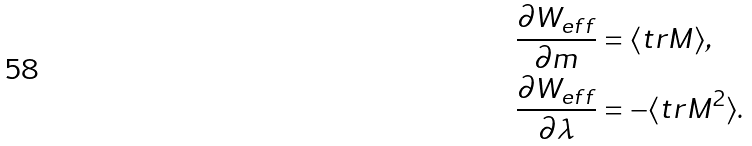<formula> <loc_0><loc_0><loc_500><loc_500>\frac { \partial W _ { e f f } } { \partial m } & = \langle t r M \rangle , \\ \frac { \partial W _ { e f f } } { \partial \lambda } & = - \langle t r M ^ { 2 } \rangle .</formula> 